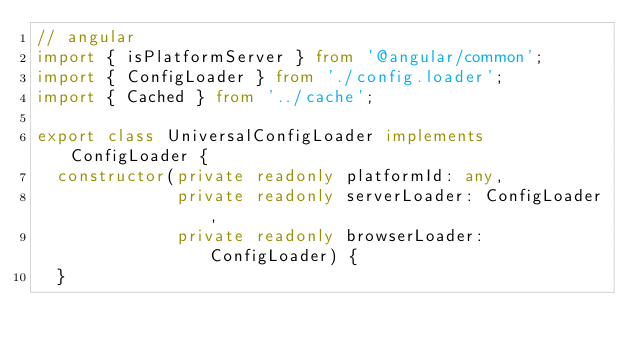<code> <loc_0><loc_0><loc_500><loc_500><_TypeScript_>// angular
import { isPlatformServer } from '@angular/common';
import { ConfigLoader } from './config.loader';
import { Cached } from '../cache';

export class UniversalConfigLoader implements ConfigLoader {
  constructor(private readonly platformId: any,
              private readonly serverLoader: ConfigLoader,
              private readonly browserLoader: ConfigLoader) {
  }
</code> 